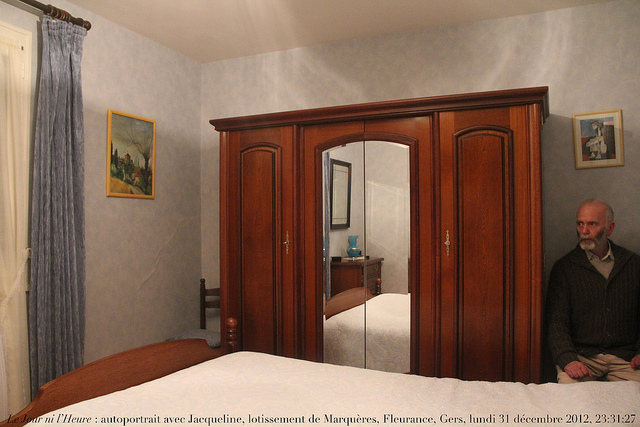Please transcribe the text in this image. Jacqueline lotisscment dc Marqueres avec 27 31 23 2012 december 3I lundi Gers Fleurance autoportrait I'Heure ni Tour Le 